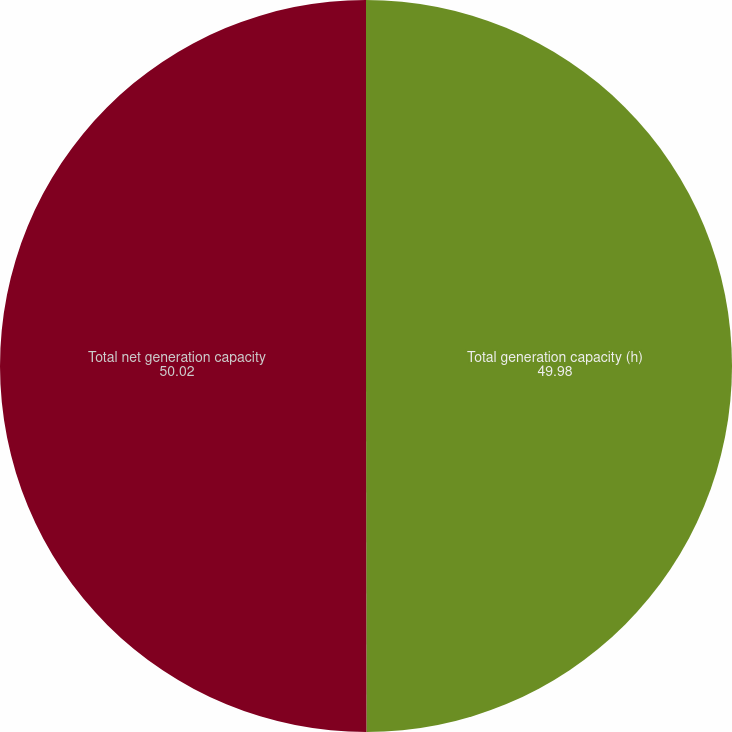Convert chart to OTSL. <chart><loc_0><loc_0><loc_500><loc_500><pie_chart><fcel>Total generation capacity (h)<fcel>Total net generation capacity<nl><fcel>49.98%<fcel>50.02%<nl></chart> 